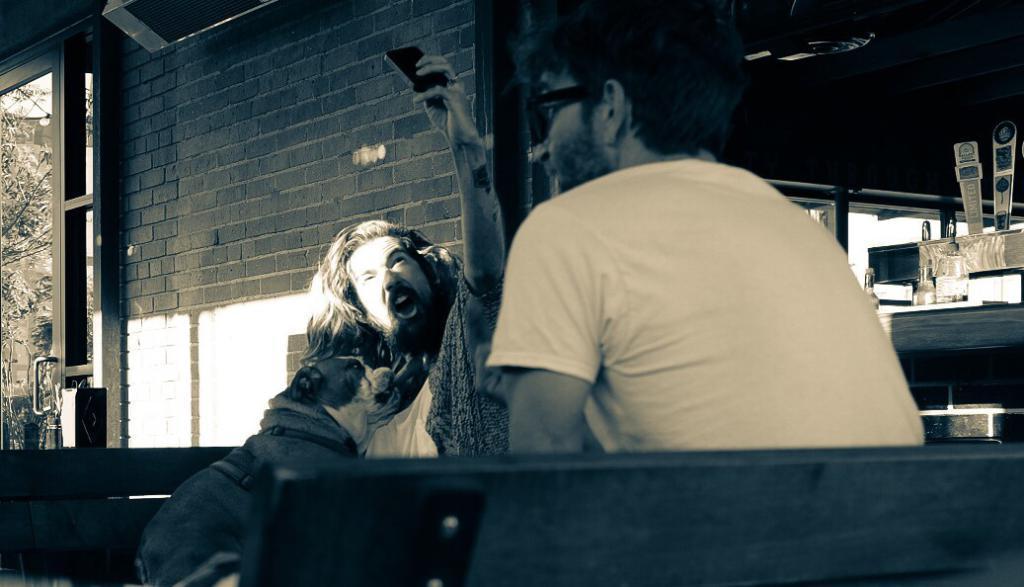In one or two sentences, can you explain what this image depicts? On the left side, there is a person holding a mobile with a hand and shouting. On the right side, there is a person in a t-shirt, sitting. In the background, there is a brick wall of a building, which is having a glass door and there are some objects. Through this glass door, we can see there are trees and there is a wall of a building. 